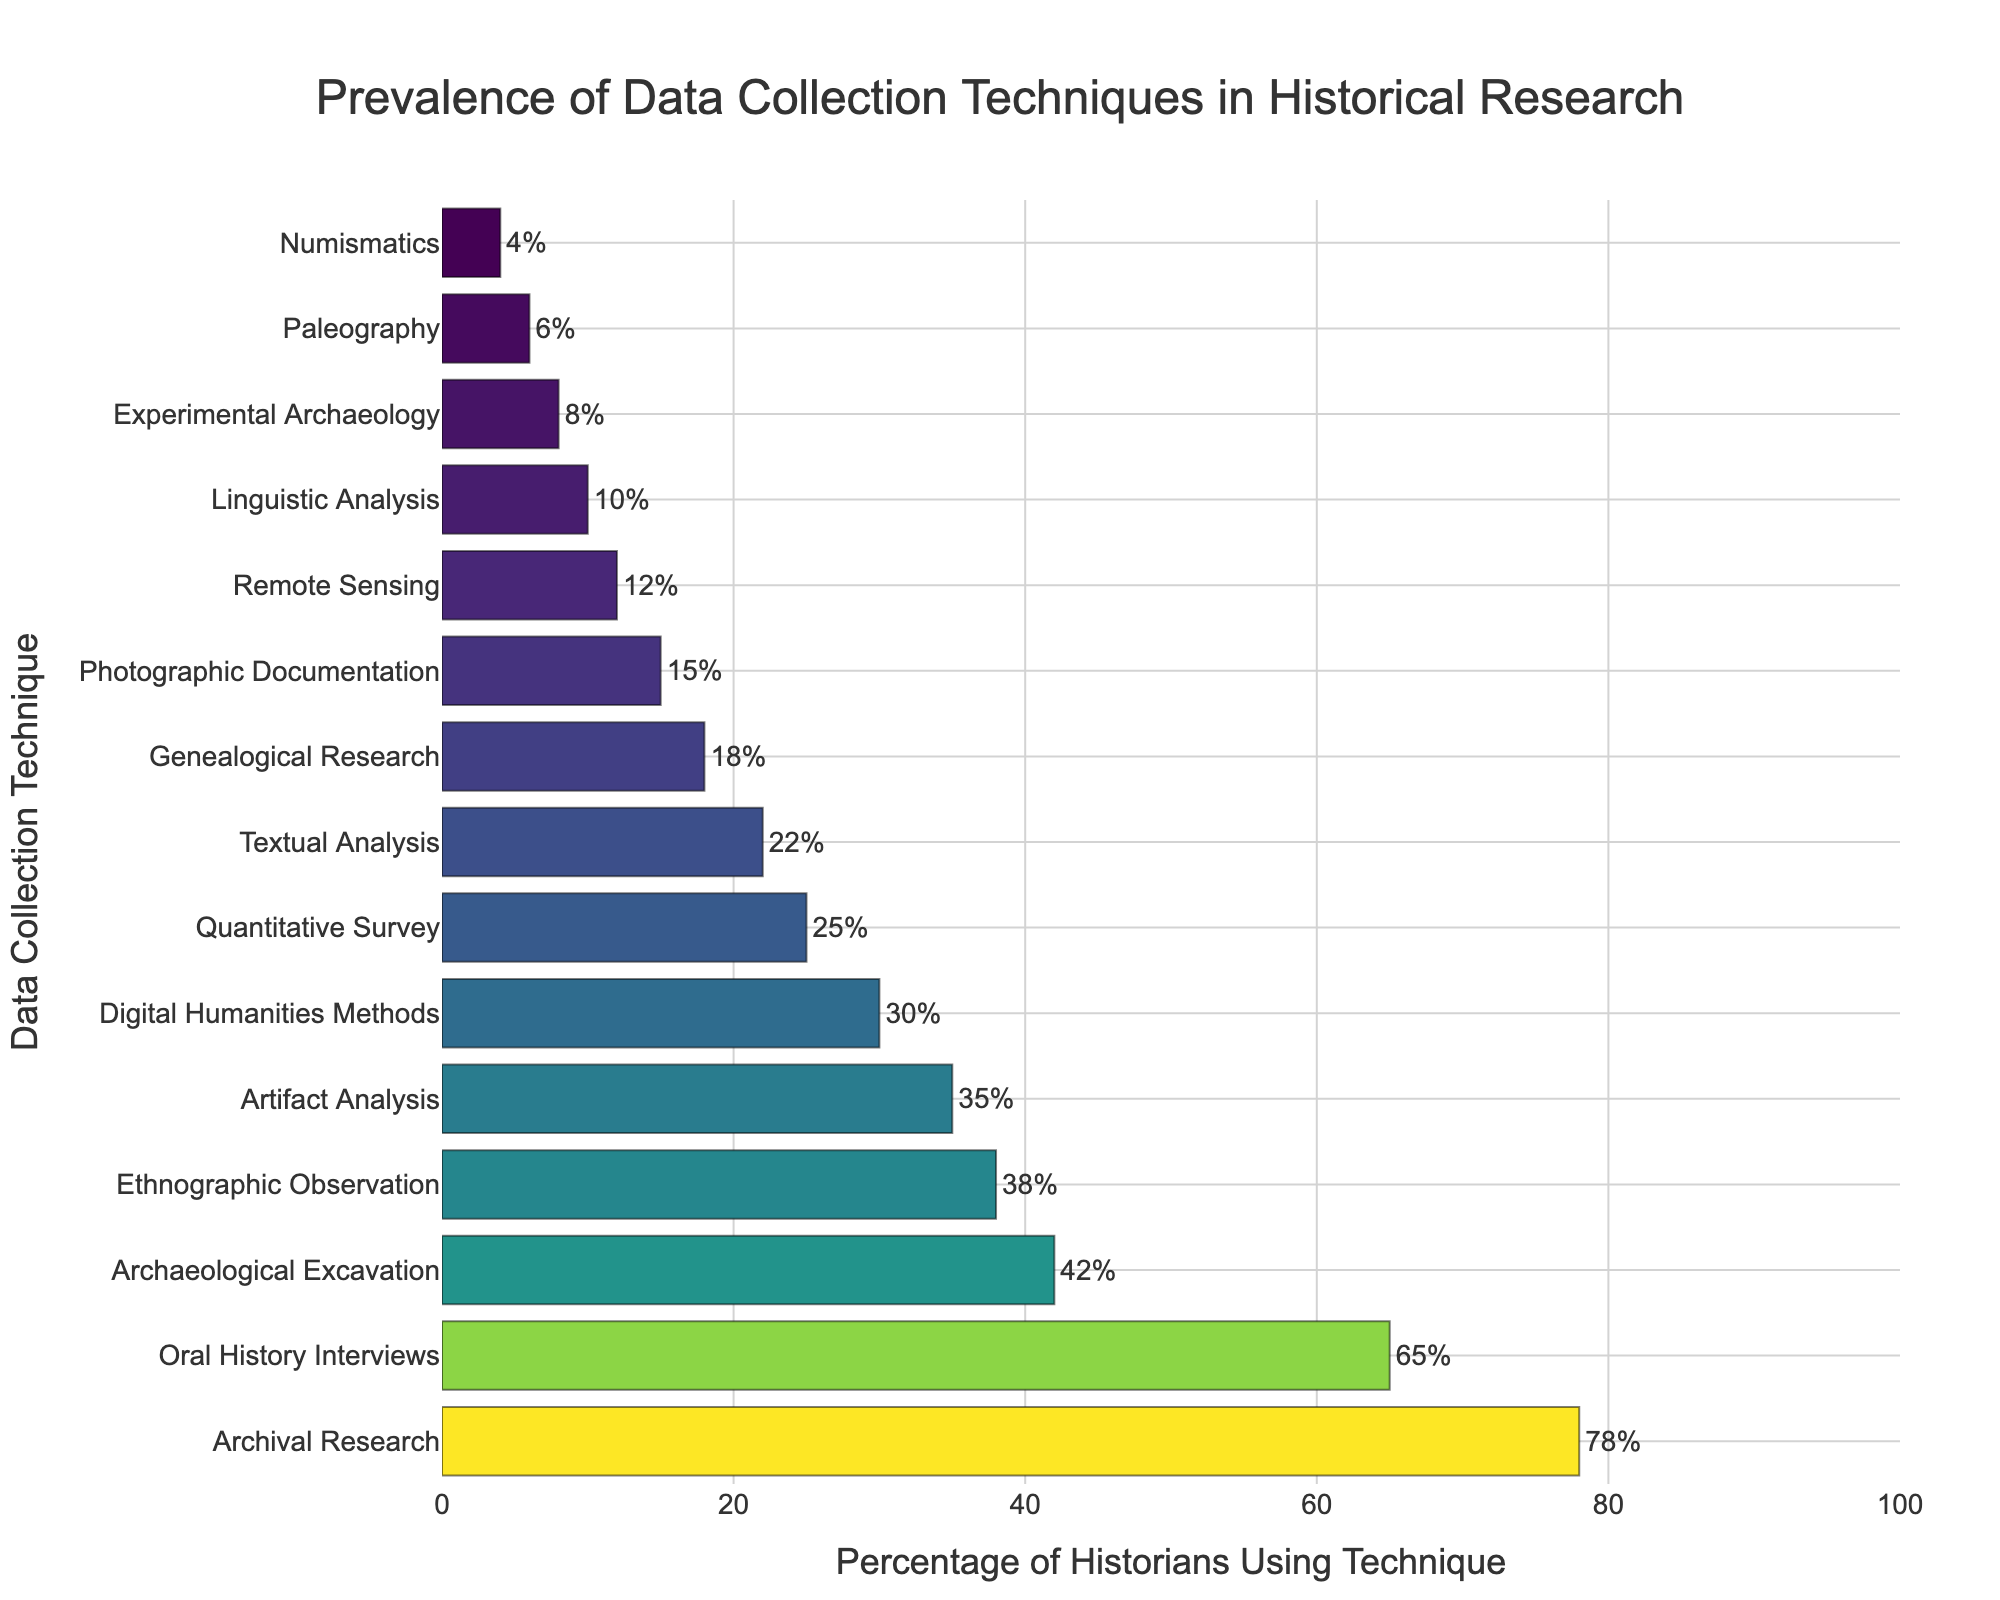Which data collection technique is the most prevalent? The bar chart shows that the highest value for the percentage is 78, which corresponds to Archival Research.
Answer: Archival Research Which technique has a higher prevalence: Oral History Interviews or Archaeological Excavation? By comparing the heights of the bars, Oral History Interviews has a percentage of 65, while Archaeological Excavation has a percentage of 42. 65 is greater than 42, so Oral History Interviews is more prevalent.
Answer: Oral History Interviews How many techniques have a prevalence of 35% or higher? The chart provides percentages for each technique. Counting the techniques with percentages 35% or higher, we have: Archival Research (78%), Oral History Interviews (65%), Archaeological Excavation (42%), Ethnographic Observation (38%), and Artifact Analysis (35%). This gives a total of 5 techniques.
Answer: 5 What is the difference in prevalence between the most and least used techniques? The highest value in the chart is 78 (Archival Research) and the lowest is 4 (Numismatics). Subtracting these gives 78 - 4 = 74.
Answer: 74 What is the combined prevalence of Digital Humanities Methods and Quantitative Survey? Digital Humanities Methods have a percentage of 30, and Quantitative Survey has 25. Adding these together gives 30 + 25 = 55.
Answer: 55 Is Genealogical Research more prevalent than Photographic Documentation? Genealogical Research has a prevalence of 18, while Photographic Documentation has a prevalence of 15. Since 18 is greater than 15, Genealogical Research is more prevalent.
Answer: Yes What percentage of historians use Textual Analysis? Looking at the bar chart, the percentage corresponding to Textual Analysis is 22.
Answer: 22% Which techniques have a prevalence between 10% and 20%? By examining the bars, the techniques with prevalence within this range are Genealogical Research (18%), Photographic Documentation (15%), and Remote Sensing (12%).
Answer: Genealogical Research, Photographic Documentation, Remote Sensing What is the prevalence of Experimental Archaeology relative to Paleography? Experimental Archaeology has a prevalence of 8, while Paleography has a prevalence of 6. 8 - 6 = 2, so Experimental Archaeology is 2 percentage points more prevalent than Paleography.
Answer: 2 percentage points Which technique has the smallest visual representation on the chart? The technique with the smallest percentage on the chart is Numismatics with 4%.
Answer: Numismatics 